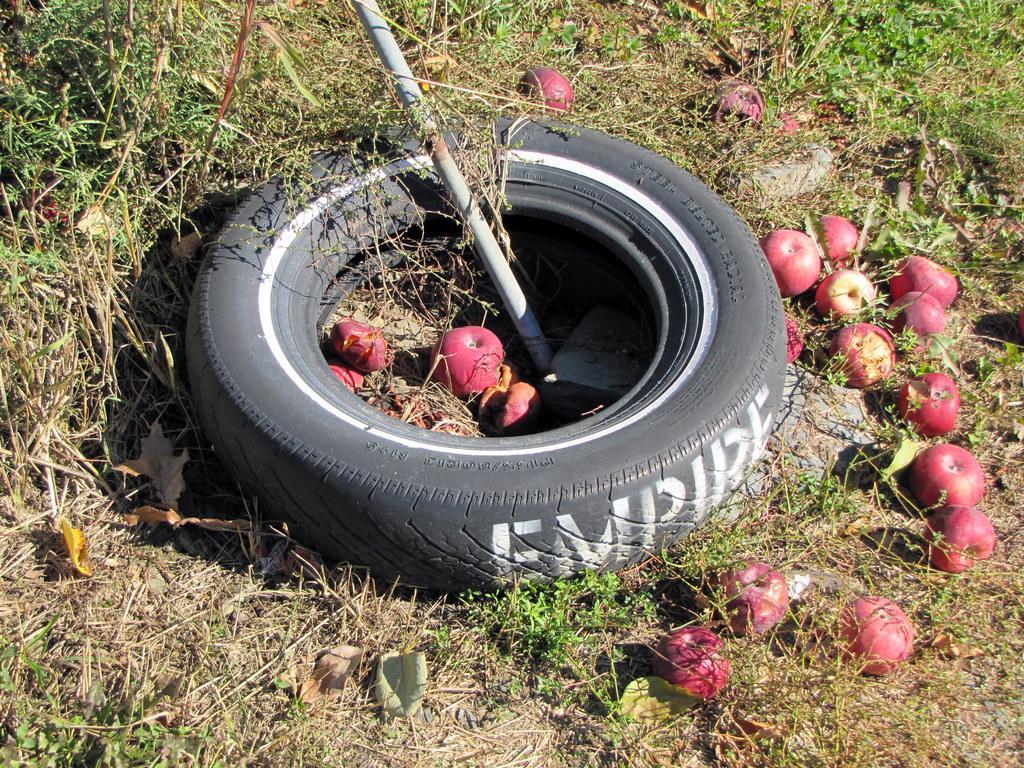Could you give a brief overview of what you see in this image? Here in this picture we can see a Tyre present in a ground, which is fully covered with grass over there and in the middle of it we can see a spade present and we can see apples present in the middle of it and beside it all over there. 